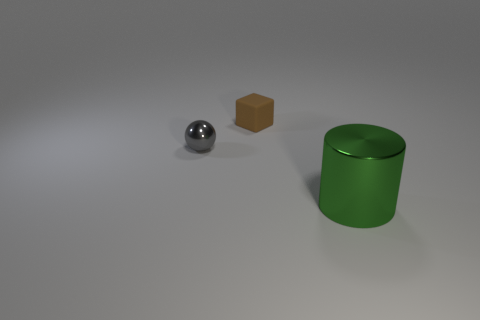What is the tiny thing that is to the left of the object behind the tiny gray object made of?
Your answer should be very brief. Metal. Are there any large gray objects that have the same material as the big green object?
Your response must be concise. No. Does the big green object have the same material as the tiny thing that is behind the gray shiny object?
Keep it short and to the point. No. What color is the object that is the same size as the brown cube?
Make the answer very short. Gray. How big is the rubber cube to the right of the metal thing that is behind the big green metallic cylinder?
Your answer should be compact. Small. There is a big metallic cylinder; is it the same color as the thing that is on the left side of the matte cube?
Your answer should be very brief. No. Are there fewer large green things that are to the left of the gray metallic sphere than gray spheres?
Your answer should be very brief. Yes. What number of other objects are there of the same size as the sphere?
Provide a short and direct response. 1. There is a metal thing to the left of the large green metal object; is its shape the same as the large metal object?
Provide a succinct answer. No. Is the number of gray spheres behind the brown object greater than the number of tiny metal things?
Give a very brief answer. No. 